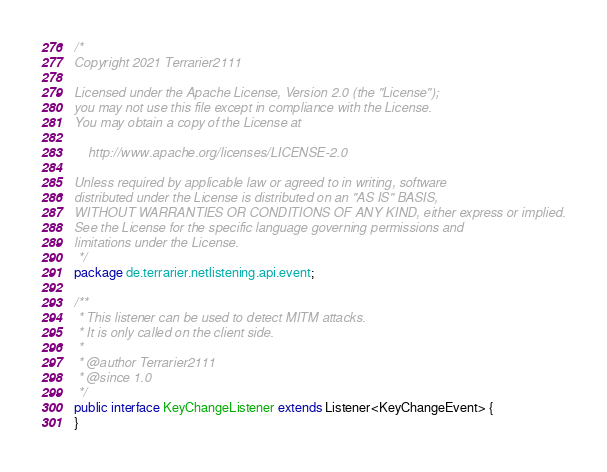Convert code to text. <code><loc_0><loc_0><loc_500><loc_500><_Java_>/*
Copyright 2021 Terrarier2111

Licensed under the Apache License, Version 2.0 (the "License");
you may not use this file except in compliance with the License.
You may obtain a copy of the License at

    http://www.apache.org/licenses/LICENSE-2.0

Unless required by applicable law or agreed to in writing, software
distributed under the License is distributed on an "AS IS" BASIS,
WITHOUT WARRANTIES OR CONDITIONS OF ANY KIND, either express or implied.
See the License for the specific language governing permissions and
limitations under the License.
 */
package de.terrarier.netlistening.api.event;

/**
 * This listener can be used to detect MITM attacks.
 * It is only called on the client side.
 *
 * @author Terrarier2111
 * @since 1.0
 */
public interface KeyChangeListener extends Listener<KeyChangeEvent> {
}
</code> 